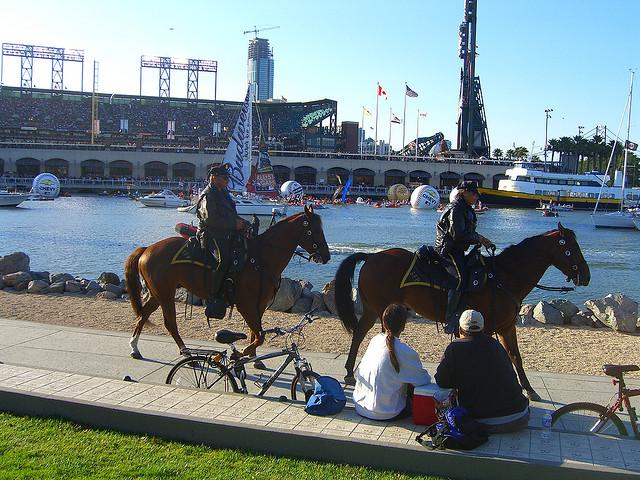How many horses are there?
Answer briefly. 2. What brand is written on the boat's sail?
Keep it brief. Budweiser. What is the red object between the couple?
Quick response, please. Cooler. 